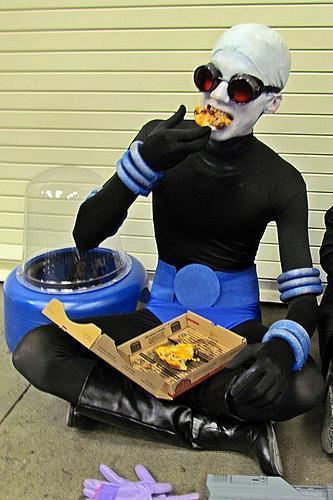How many people?
Give a very brief answer. 1. 